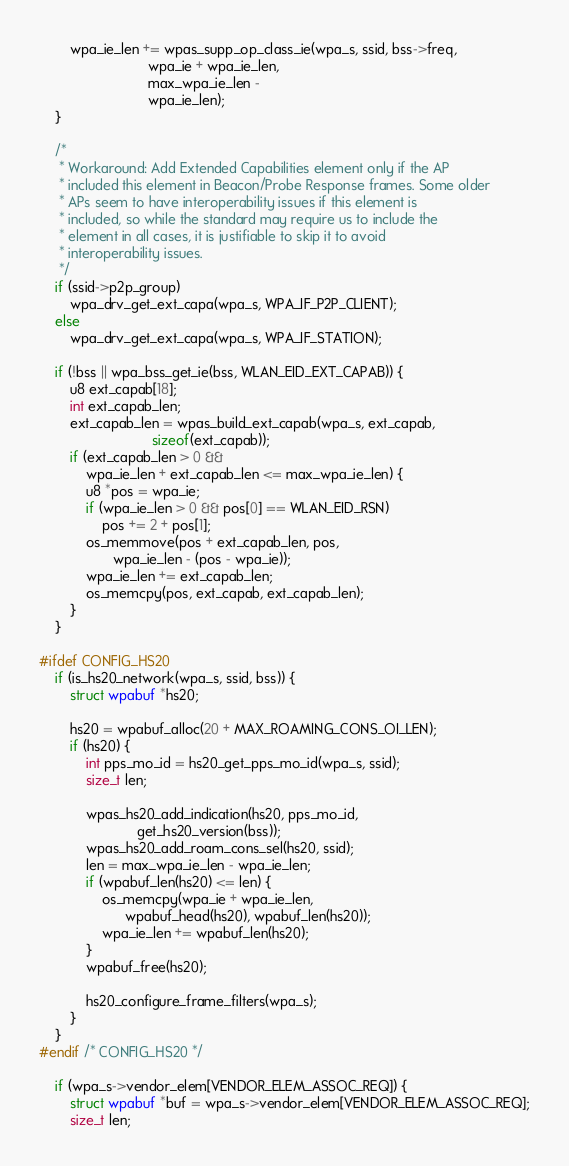<code> <loc_0><loc_0><loc_500><loc_500><_C_>		wpa_ie_len += wpas_supp_op_class_ie(wpa_s, ssid, bss->freq,
						    wpa_ie + wpa_ie_len,
						    max_wpa_ie_len -
						    wpa_ie_len);
	}

	/*
	 * Workaround: Add Extended Capabilities element only if the AP
	 * included this element in Beacon/Probe Response frames. Some older
	 * APs seem to have interoperability issues if this element is
	 * included, so while the standard may require us to include the
	 * element in all cases, it is justifiable to skip it to avoid
	 * interoperability issues.
	 */
	if (ssid->p2p_group)
		wpa_drv_get_ext_capa(wpa_s, WPA_IF_P2P_CLIENT);
	else
		wpa_drv_get_ext_capa(wpa_s, WPA_IF_STATION);

	if (!bss || wpa_bss_get_ie(bss, WLAN_EID_EXT_CAPAB)) {
		u8 ext_capab[18];
		int ext_capab_len;
		ext_capab_len = wpas_build_ext_capab(wpa_s, ext_capab,
						     sizeof(ext_capab));
		if (ext_capab_len > 0 &&
		    wpa_ie_len + ext_capab_len <= max_wpa_ie_len) {
			u8 *pos = wpa_ie;
			if (wpa_ie_len > 0 && pos[0] == WLAN_EID_RSN)
				pos += 2 + pos[1];
			os_memmove(pos + ext_capab_len, pos,
				   wpa_ie_len - (pos - wpa_ie));
			wpa_ie_len += ext_capab_len;
			os_memcpy(pos, ext_capab, ext_capab_len);
		}
	}

#ifdef CONFIG_HS20
	if (is_hs20_network(wpa_s, ssid, bss)) {
		struct wpabuf *hs20;

		hs20 = wpabuf_alloc(20 + MAX_ROAMING_CONS_OI_LEN);
		if (hs20) {
			int pps_mo_id = hs20_get_pps_mo_id(wpa_s, ssid);
			size_t len;

			wpas_hs20_add_indication(hs20, pps_mo_id,
						 get_hs20_version(bss));
			wpas_hs20_add_roam_cons_sel(hs20, ssid);
			len = max_wpa_ie_len - wpa_ie_len;
			if (wpabuf_len(hs20) <= len) {
				os_memcpy(wpa_ie + wpa_ie_len,
					  wpabuf_head(hs20), wpabuf_len(hs20));
				wpa_ie_len += wpabuf_len(hs20);
			}
			wpabuf_free(hs20);

			hs20_configure_frame_filters(wpa_s);
		}
	}
#endif /* CONFIG_HS20 */

	if (wpa_s->vendor_elem[VENDOR_ELEM_ASSOC_REQ]) {
		struct wpabuf *buf = wpa_s->vendor_elem[VENDOR_ELEM_ASSOC_REQ];
		size_t len;
</code> 